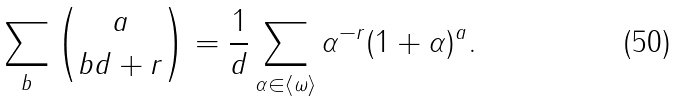<formula> <loc_0><loc_0><loc_500><loc_500>\sum _ { b } \binom { a } { b d + r } = \frac { 1 } { d } \sum _ { \alpha \in \langle \omega \rangle } \alpha ^ { - r } ( 1 + \alpha ) ^ { a } .</formula> 